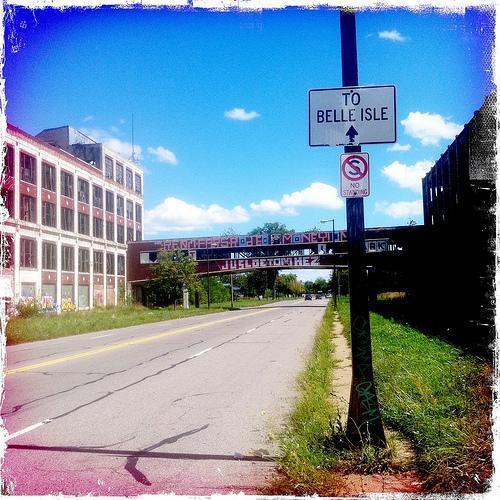How many signs?
Give a very brief answer. 2. How many signs are on the pole?
Give a very brief answer. 2. 